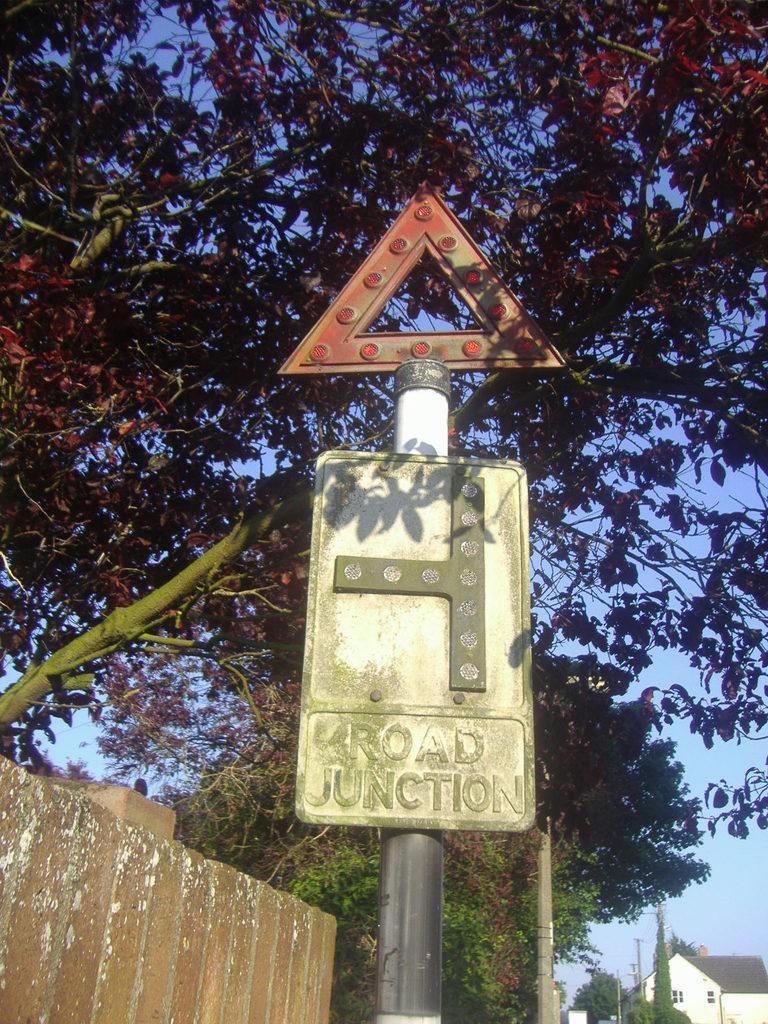How would you summarize this image in a sentence or two? In this image we can see one house, some poles, few boards with poles, one wall on the left side of the image, some trees on the ground and there is the sky in the background. 